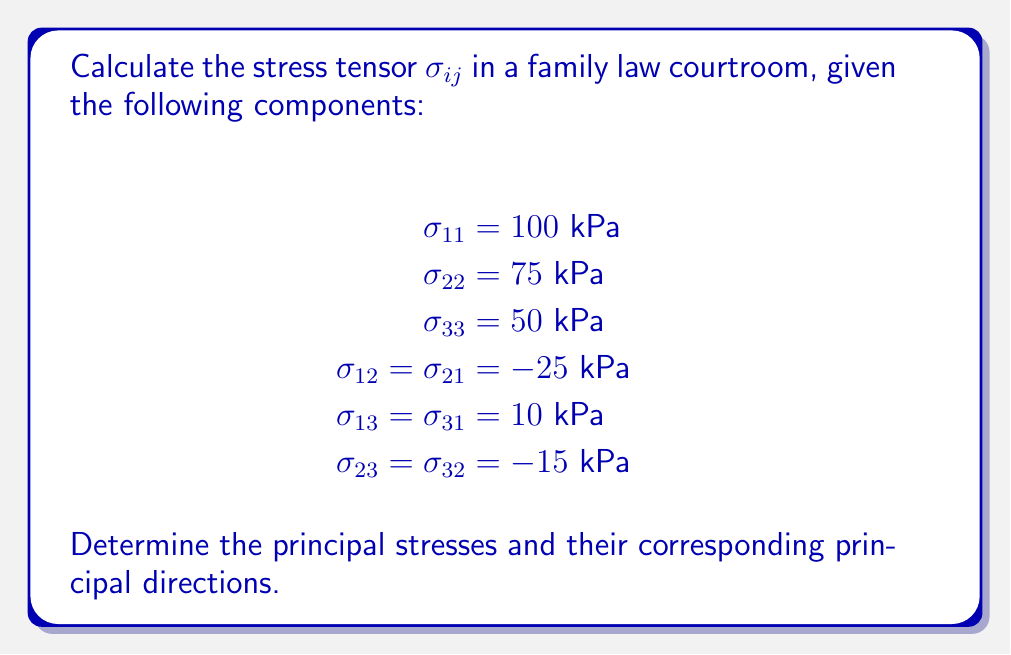Could you help me with this problem? To solve this problem, we'll follow these steps:

1) First, we need to construct the stress tensor $\sigma_{ij}$ using the given components:

$$\sigma_{ij} = \begin{pmatrix}
100 & -25 & 10 \\
-25 & 75 & -15 \\
10 & -15 & 50
\end{pmatrix} \text{ kPa}$$

2) To find the principal stresses, we need to solve the characteristic equation:

$$\det(\sigma_{ij} - \lambda I) = 0$$

Where $\lambda$ represents the principal stresses and $I$ is the identity matrix.

3) Expanding the determinant:

$$\begin{vmatrix}
100-\lambda & -25 & 10 \\
-25 & 75-\lambda & -15 \\
10 & -15 & 50-\lambda
\end{vmatrix} = 0$$

4) This leads to the cubic equation:

$$-\lambda^3 + 225\lambda^2 - 14625\lambda + 281250 = 0$$

5) Solving this equation (using numerical methods, as it's too complex for manual solving) gives us the principal stresses:

$$\lambda_1 \approx 115.8 \text{ kPa}$$
$$\lambda_2 \approx 77.4 \text{ kPa}$$
$$\lambda_3 \approx 31.8 \text{ kPa}$$

6) To find the principal directions, we need to solve the eigenvector equation for each principal stress:

$$(\sigma_{ij} - \lambda_k I)\vec{v_k} = 0$$

7) Solving these equations gives us the normalized principal directions:

$$\vec{v_1} \approx (0.816, -0.571, 0.089)$$
$$\vec{v_2} \approx (-0.492, -0.784, -0.378)$$
$$\vec{v_3} \approx (0.301, 0.242, -0.922)$$

These directions represent the orientations of maximum, intermediate, and minimum stress in the courtroom, respectively.
Answer: Principal stresses: $\lambda_1 \approx 115.8 \text{ kPa}$, $\lambda_2 \approx 77.4 \text{ kPa}$, $\lambda_3 \approx 31.8 \text{ kPa}$
Principal directions: $\vec{v_1} \approx (0.816, -0.571, 0.089)$, $\vec{v_2} \approx (-0.492, -0.784, -0.378)$, $\vec{v_3} \approx (0.301, 0.242, -0.922)$ 